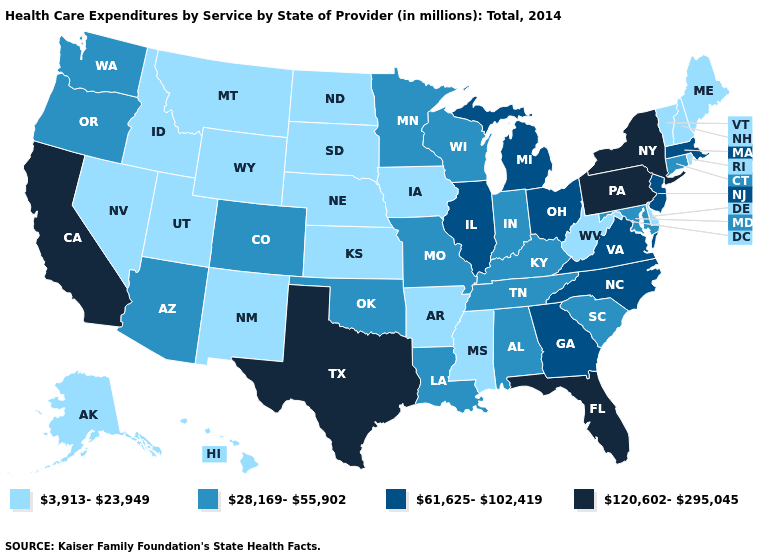What is the highest value in the MidWest ?
Be succinct. 61,625-102,419. Does Pennsylvania have the highest value in the USA?
Be succinct. Yes. What is the lowest value in the South?
Quick response, please. 3,913-23,949. Name the states that have a value in the range 3,913-23,949?
Answer briefly. Alaska, Arkansas, Delaware, Hawaii, Idaho, Iowa, Kansas, Maine, Mississippi, Montana, Nebraska, Nevada, New Hampshire, New Mexico, North Dakota, Rhode Island, South Dakota, Utah, Vermont, West Virginia, Wyoming. Among the states that border Alabama , which have the lowest value?
Be succinct. Mississippi. What is the highest value in the West ?
Be succinct. 120,602-295,045. What is the highest value in states that border Utah?
Quick response, please. 28,169-55,902. What is the lowest value in the USA?
Answer briefly. 3,913-23,949. Among the states that border Kansas , which have the lowest value?
Keep it brief. Nebraska. Does the map have missing data?
Short answer required. No. What is the highest value in the USA?
Short answer required. 120,602-295,045. Among the states that border Iowa , does South Dakota have the highest value?
Answer briefly. No. Name the states that have a value in the range 120,602-295,045?
Be succinct. California, Florida, New York, Pennsylvania, Texas. Name the states that have a value in the range 3,913-23,949?
Keep it brief. Alaska, Arkansas, Delaware, Hawaii, Idaho, Iowa, Kansas, Maine, Mississippi, Montana, Nebraska, Nevada, New Hampshire, New Mexico, North Dakota, Rhode Island, South Dakota, Utah, Vermont, West Virginia, Wyoming. Name the states that have a value in the range 28,169-55,902?
Be succinct. Alabama, Arizona, Colorado, Connecticut, Indiana, Kentucky, Louisiana, Maryland, Minnesota, Missouri, Oklahoma, Oregon, South Carolina, Tennessee, Washington, Wisconsin. 